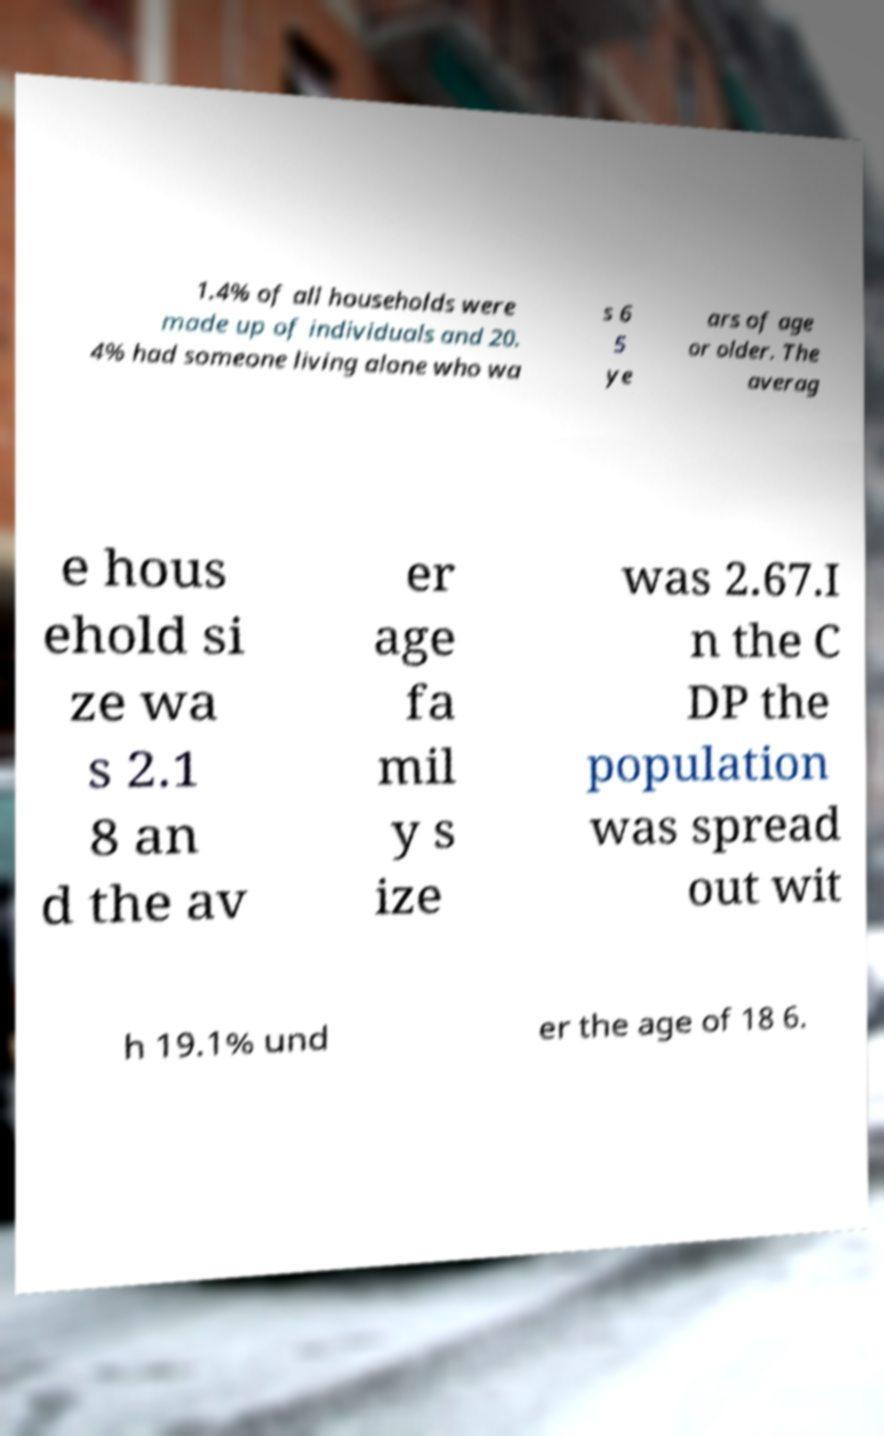Could you assist in decoding the text presented in this image and type it out clearly? 1.4% of all households were made up of individuals and 20. 4% had someone living alone who wa s 6 5 ye ars of age or older. The averag e hous ehold si ze wa s 2.1 8 an d the av er age fa mil y s ize was 2.67.I n the C DP the population was spread out wit h 19.1% und er the age of 18 6. 